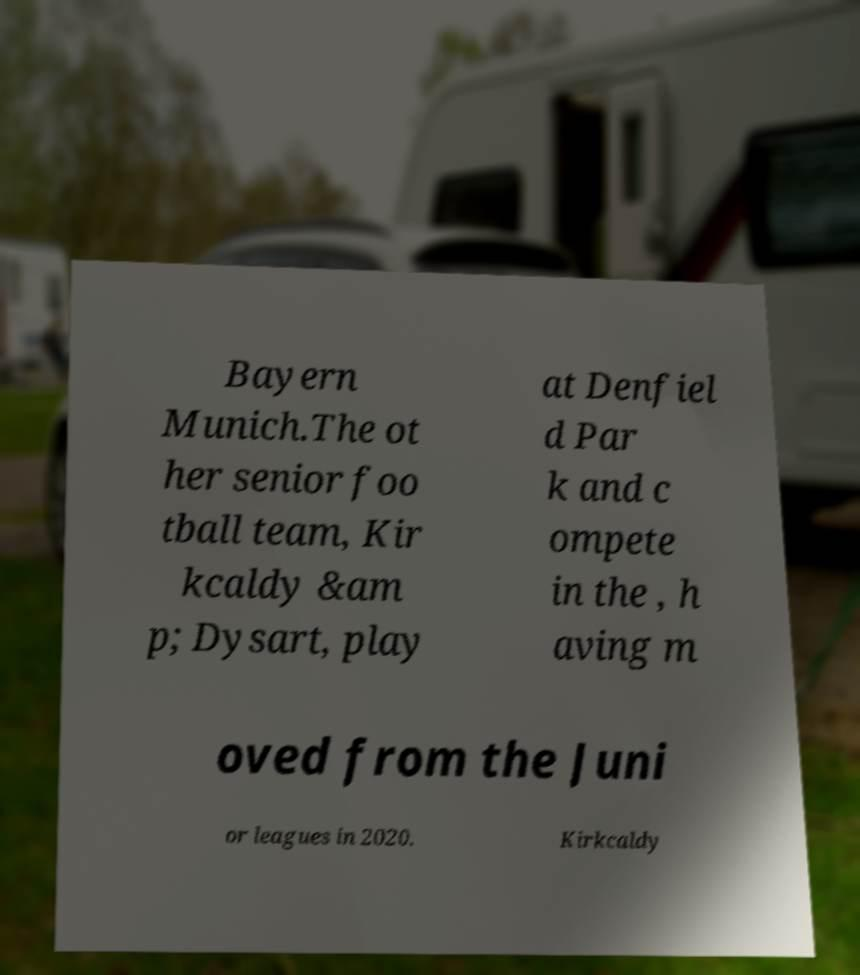For documentation purposes, I need the text within this image transcribed. Could you provide that? Bayern Munich.The ot her senior foo tball team, Kir kcaldy &am p; Dysart, play at Denfiel d Par k and c ompete in the , h aving m oved from the Juni or leagues in 2020. Kirkcaldy 